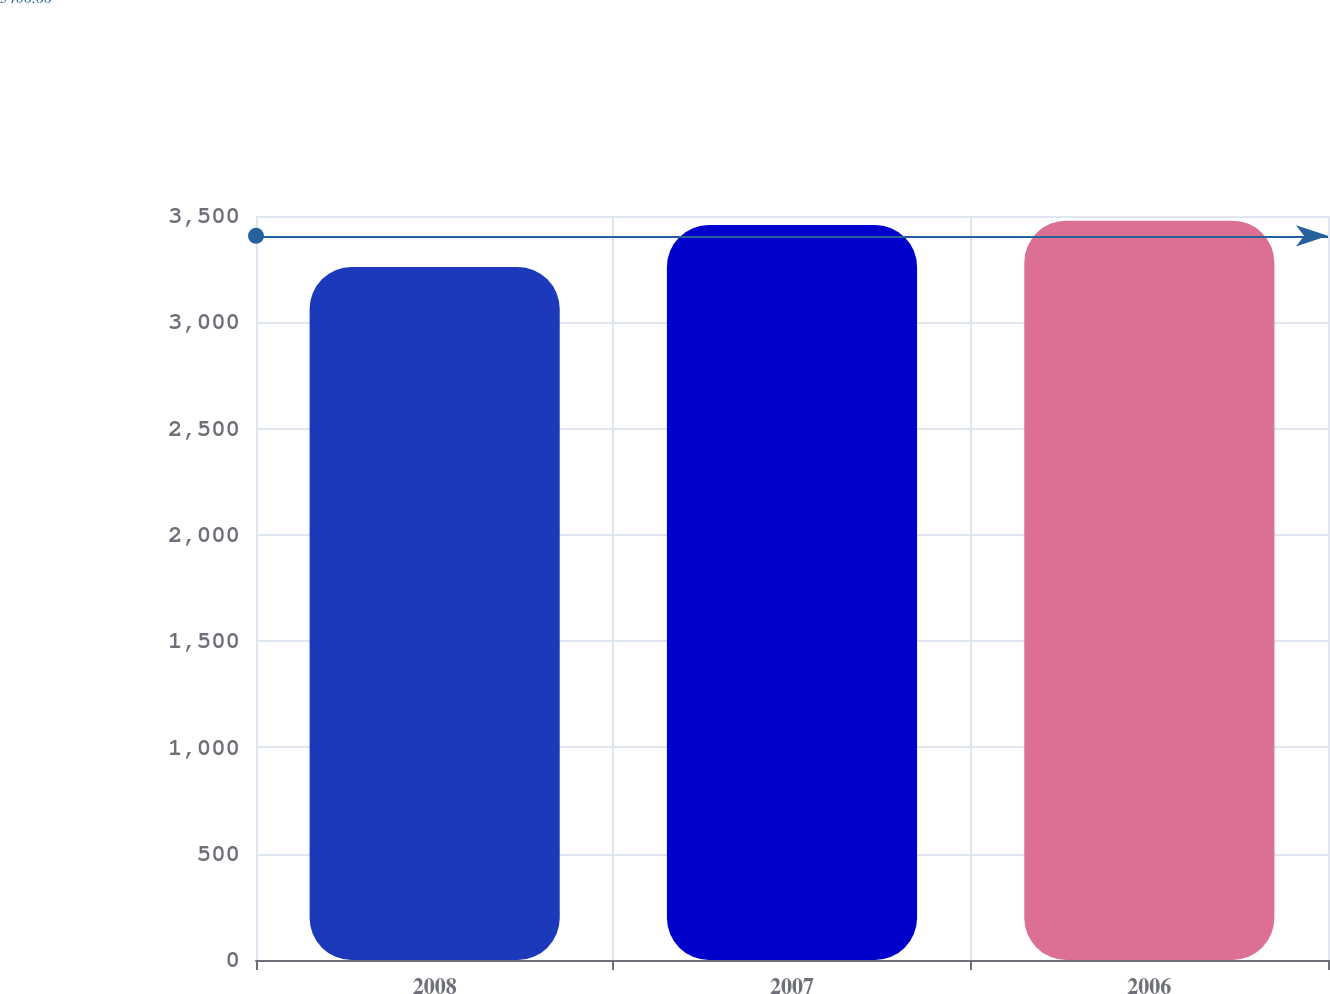Convert chart. <chart><loc_0><loc_0><loc_500><loc_500><bar_chart><fcel>2008<fcel>2007<fcel>2006<nl><fcel>3260<fcel>3458<fcel>3478.1<nl></chart> 